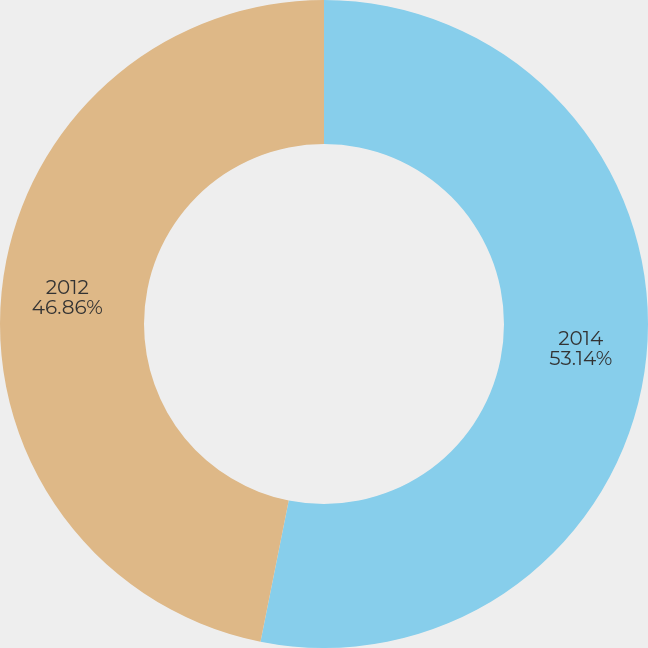Convert chart. <chart><loc_0><loc_0><loc_500><loc_500><pie_chart><fcel>2014<fcel>2012<nl><fcel>53.14%<fcel>46.86%<nl></chart> 